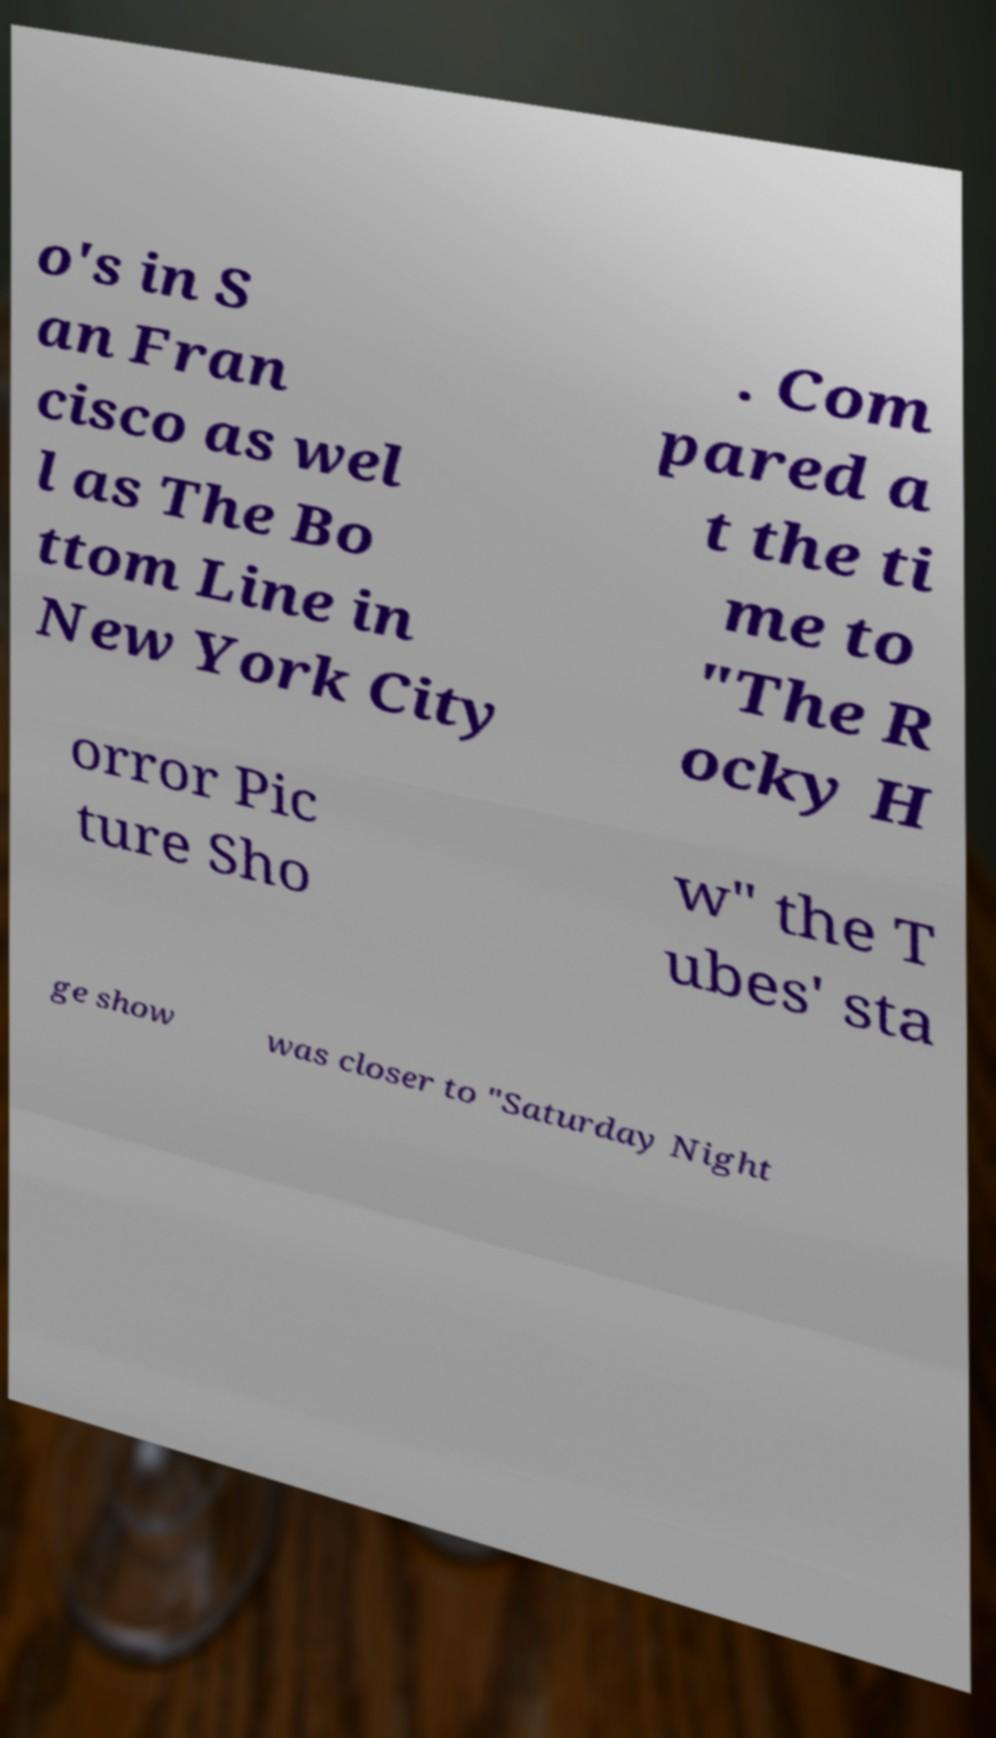What messages or text are displayed in this image? I need them in a readable, typed format. o's in S an Fran cisco as wel l as The Bo ttom Line in New York City . Com pared a t the ti me to "The R ocky H orror Pic ture Sho w" the T ubes' sta ge show was closer to "Saturday Night 